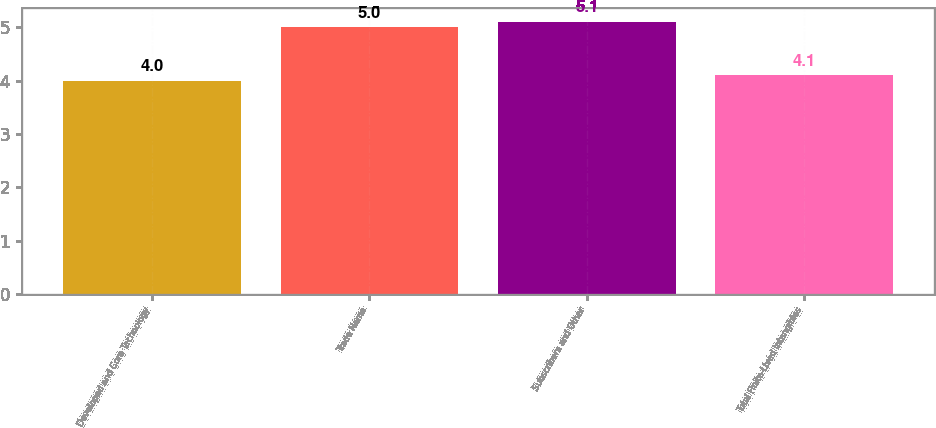<chart> <loc_0><loc_0><loc_500><loc_500><bar_chart><fcel>Developed and Core Technology<fcel>Trade Name<fcel>Subscribers and Other<fcel>Total Finite-Lived Intangibles<nl><fcel>4<fcel>5<fcel>5.1<fcel>4.1<nl></chart> 